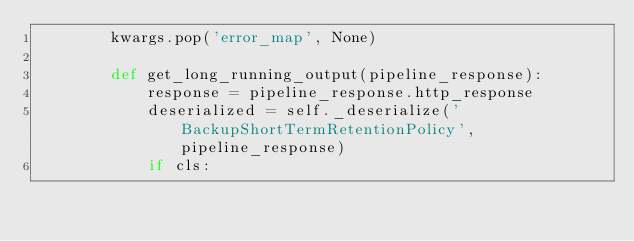<code> <loc_0><loc_0><loc_500><loc_500><_Python_>        kwargs.pop('error_map', None)

        def get_long_running_output(pipeline_response):
            response = pipeline_response.http_response
            deserialized = self._deserialize('BackupShortTermRetentionPolicy', pipeline_response)
            if cls:</code> 